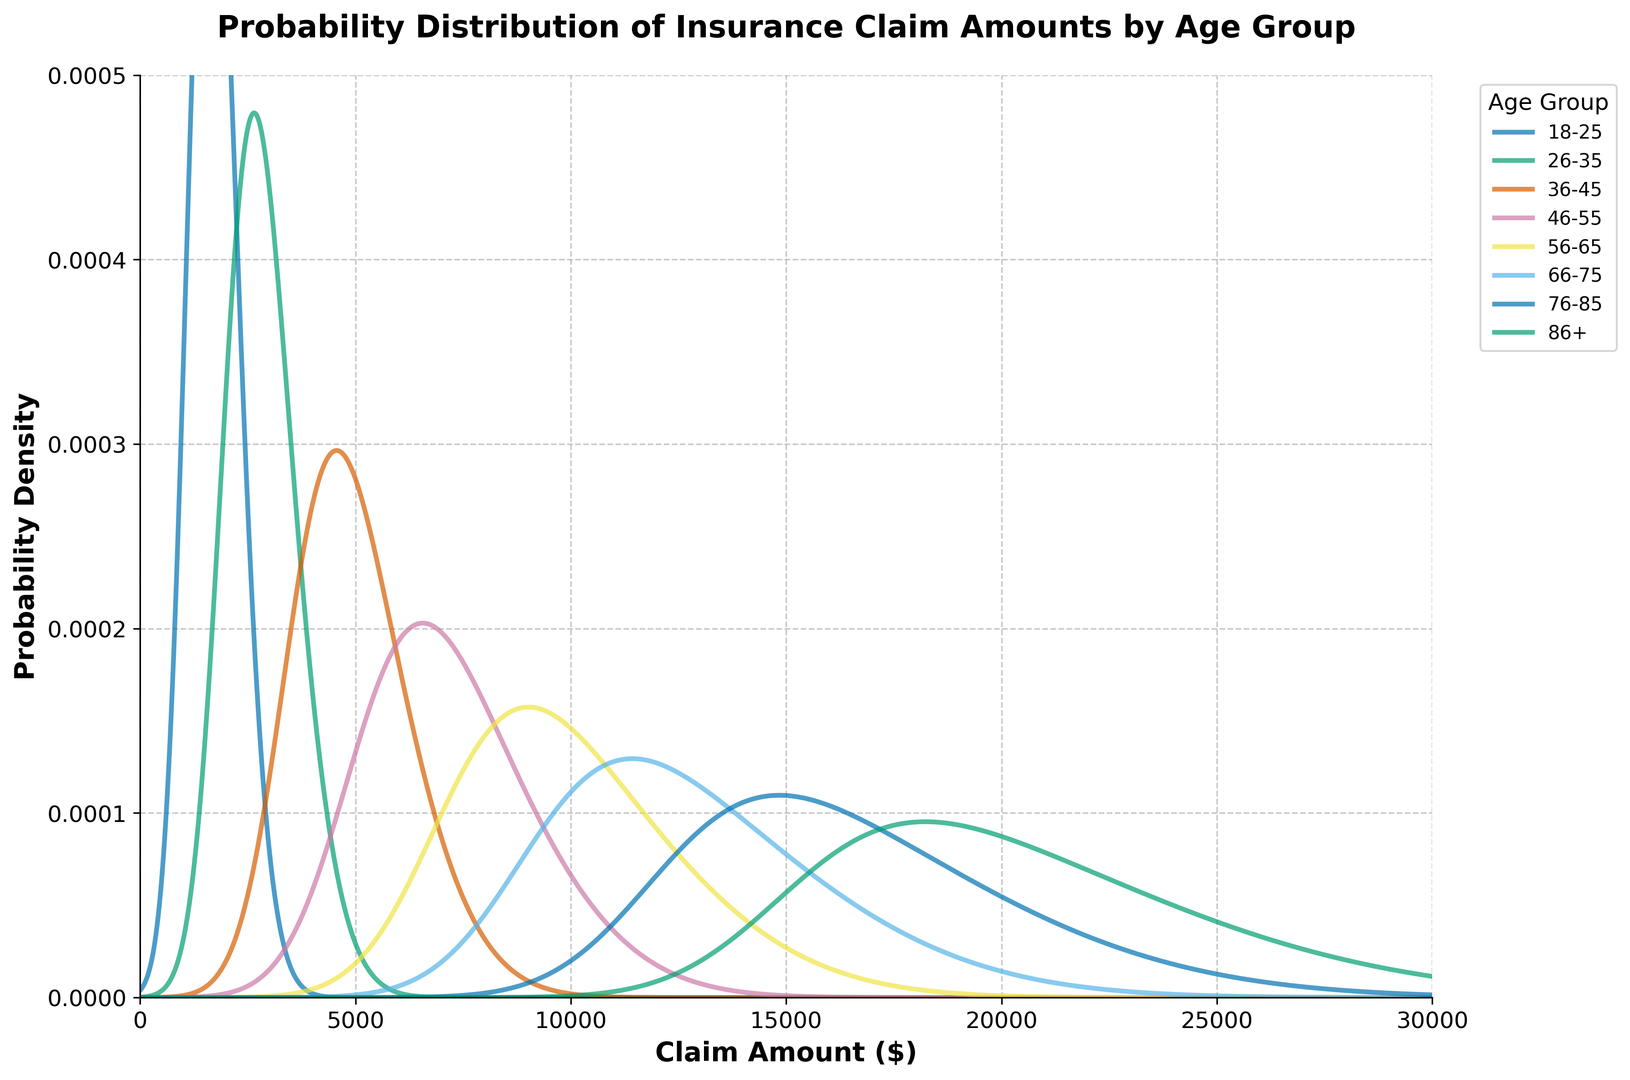Which age group has the highest claim amount distribution peak? By observing the peaks of the probability density functions, the age group with the highest claim amount peak has the highest mean claim amount and skewness. The 86+ age group has the peak farthest to the right indicating the highest claim amount distribution.
Answer: 86+ Which age group has the lowest standard deviation in claim amounts? The width of the probability density functions indicates the standard deviation; narrower distributions correspond to lower standard deviations. The 18-25 age group has the narrowest distribution.
Answer: 18-25 Compare the skewness of the 46-55 and 56-65 age groups. Which has a higher value? The skewness can be seen by the asymmetry of the distribution. The 56-65 age group is more skewed to the right compared to the 46-55 age group, indicating a higher skewness value.
Answer: 56-65 What is the difference between the mean claim amounts of the 36-45 and 66-75 age groups? The mean claim amounts are indicated by the peaks of the distribution curves. Subtracting the mean of the 36-45 age group (3500) from the 66-75 age group (9000) gives the difference.
Answer: 5500 Based on visual analysis, which age group has the claim amount distribution with the least probability density? Identifying the lowest peak height among distributions will show the group with the least probability density. The 18-25 age group has the lowest peak height.
Answer: 18-25 Does the 56-65 age group have a wider distribution than the 76-85 age group? Comparing the width of the probability density functions for the two groups provides this information. The 56-65 and 76-85 group distributions have comparable spreads, but 76-85 is slightly wider.
Answer: No Which age group’s claim amount distribution is skewed the most to the right? The group with the highest skewness will have the most right-skewed distribution. According to the plot, the 86+ age group's distribution is the most skewed to the right.
Answer: 86+ By what percentage does the mean claim amount of the 66-75 age group exceed that of the 46-55 age group? Calculate the difference in mean claim amounts (9000 - 5000 = 4000), then divide by the mean claim amount of the 46-55 group and multiply by 100, resulting in (4000 / 5000) * 100.
Answer: 80% 